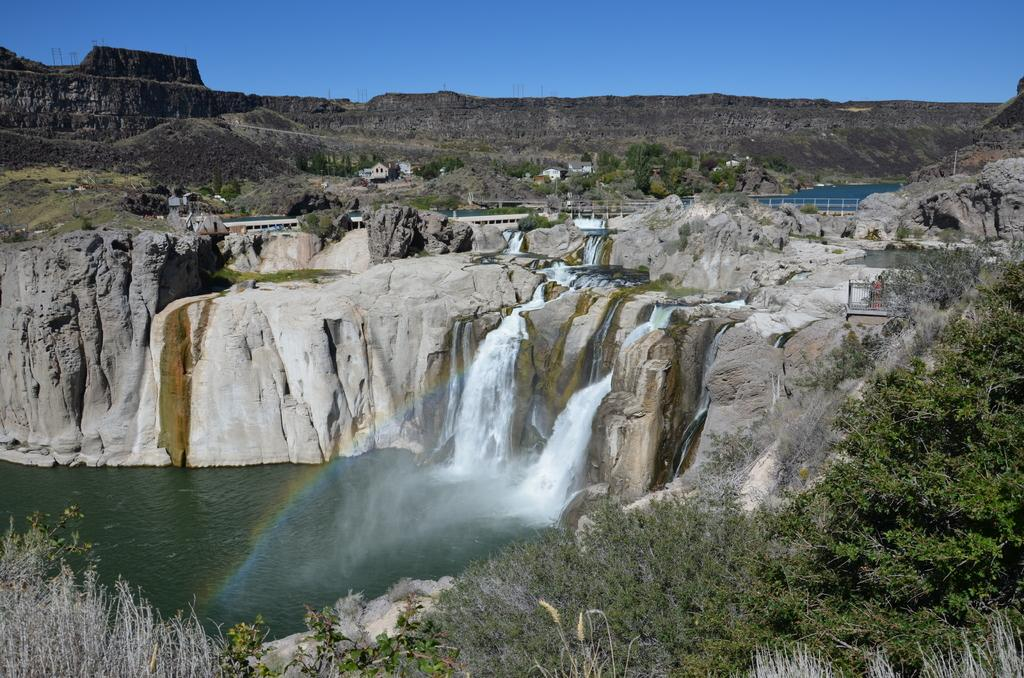What is the source of the water in the image? There is water flowing from a mountain in the image. Where does the water flow after leaving the mountain? The water flows into a water pond. What type of vegetation is on the right side of the image? There are trees on the right side of the image. What can be seen in the background of the image? There are mountains visible in the background, and the sky is blue. What type of locket is hanging from the tree on the right side of the image? There is no locket present in the image; it features water flowing from a mountain, a water pond, trees, mountains, and a blue sky. 